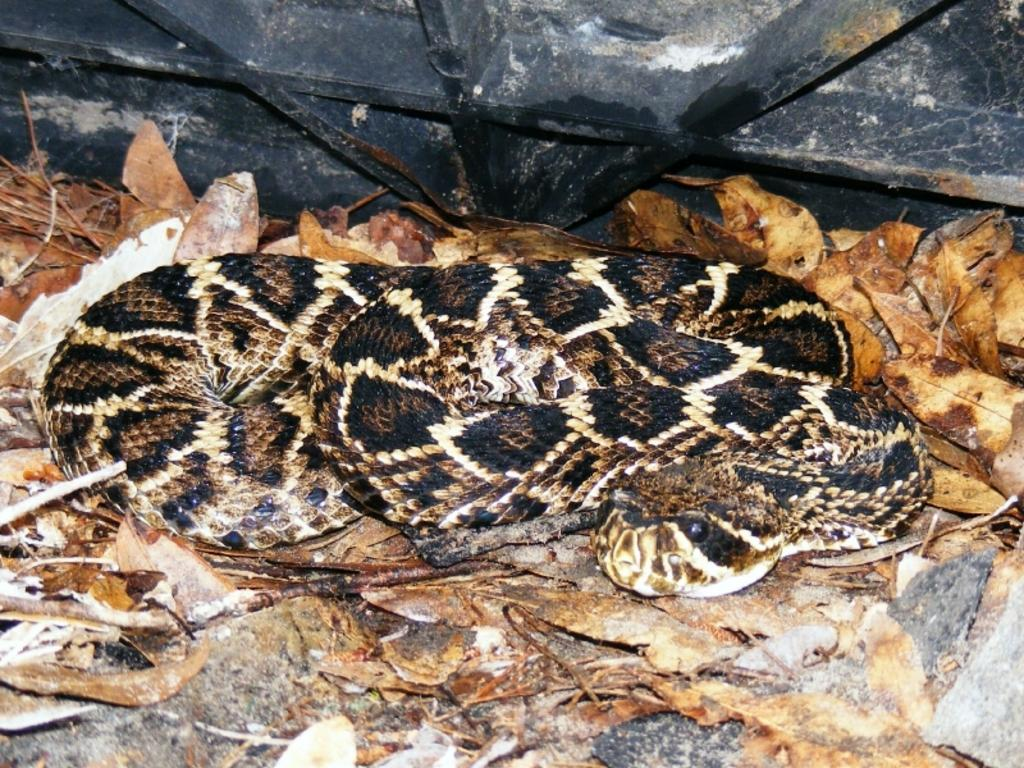What is the main subject in the foreground of the image? There is a snake in the foreground of the image. What else can be seen in the foreground of the image? There are dry leaves in the foreground of the image. What is the black object at the top of the image? The black object at the top of the image is not clearly identifiable from the provided facts. How does the giraffe balance itself on the dry leaves in the image? There is no giraffe present in the image; it only features a snake and dry leaves. 